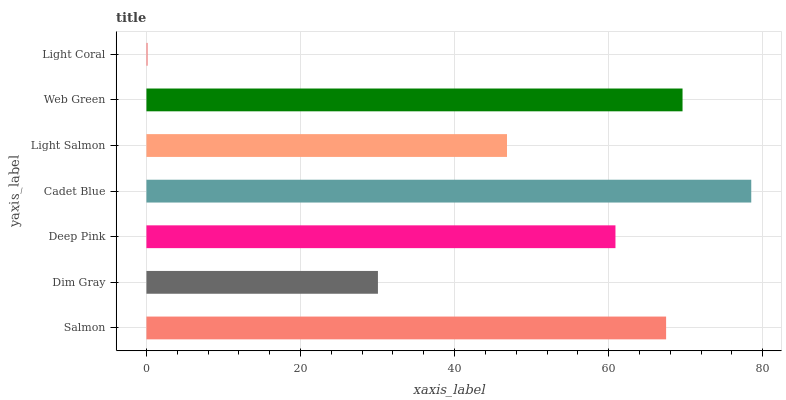Is Light Coral the minimum?
Answer yes or no. Yes. Is Cadet Blue the maximum?
Answer yes or no. Yes. Is Dim Gray the minimum?
Answer yes or no. No. Is Dim Gray the maximum?
Answer yes or no. No. Is Salmon greater than Dim Gray?
Answer yes or no. Yes. Is Dim Gray less than Salmon?
Answer yes or no. Yes. Is Dim Gray greater than Salmon?
Answer yes or no. No. Is Salmon less than Dim Gray?
Answer yes or no. No. Is Deep Pink the high median?
Answer yes or no. Yes. Is Deep Pink the low median?
Answer yes or no. Yes. Is Web Green the high median?
Answer yes or no. No. Is Light Salmon the low median?
Answer yes or no. No. 